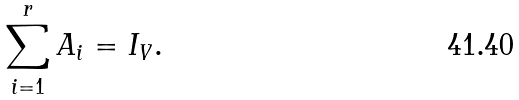Convert formula to latex. <formula><loc_0><loc_0><loc_500><loc_500>\sum _ { i = 1 } ^ { r } A _ { i } = I _ { V } .</formula> 